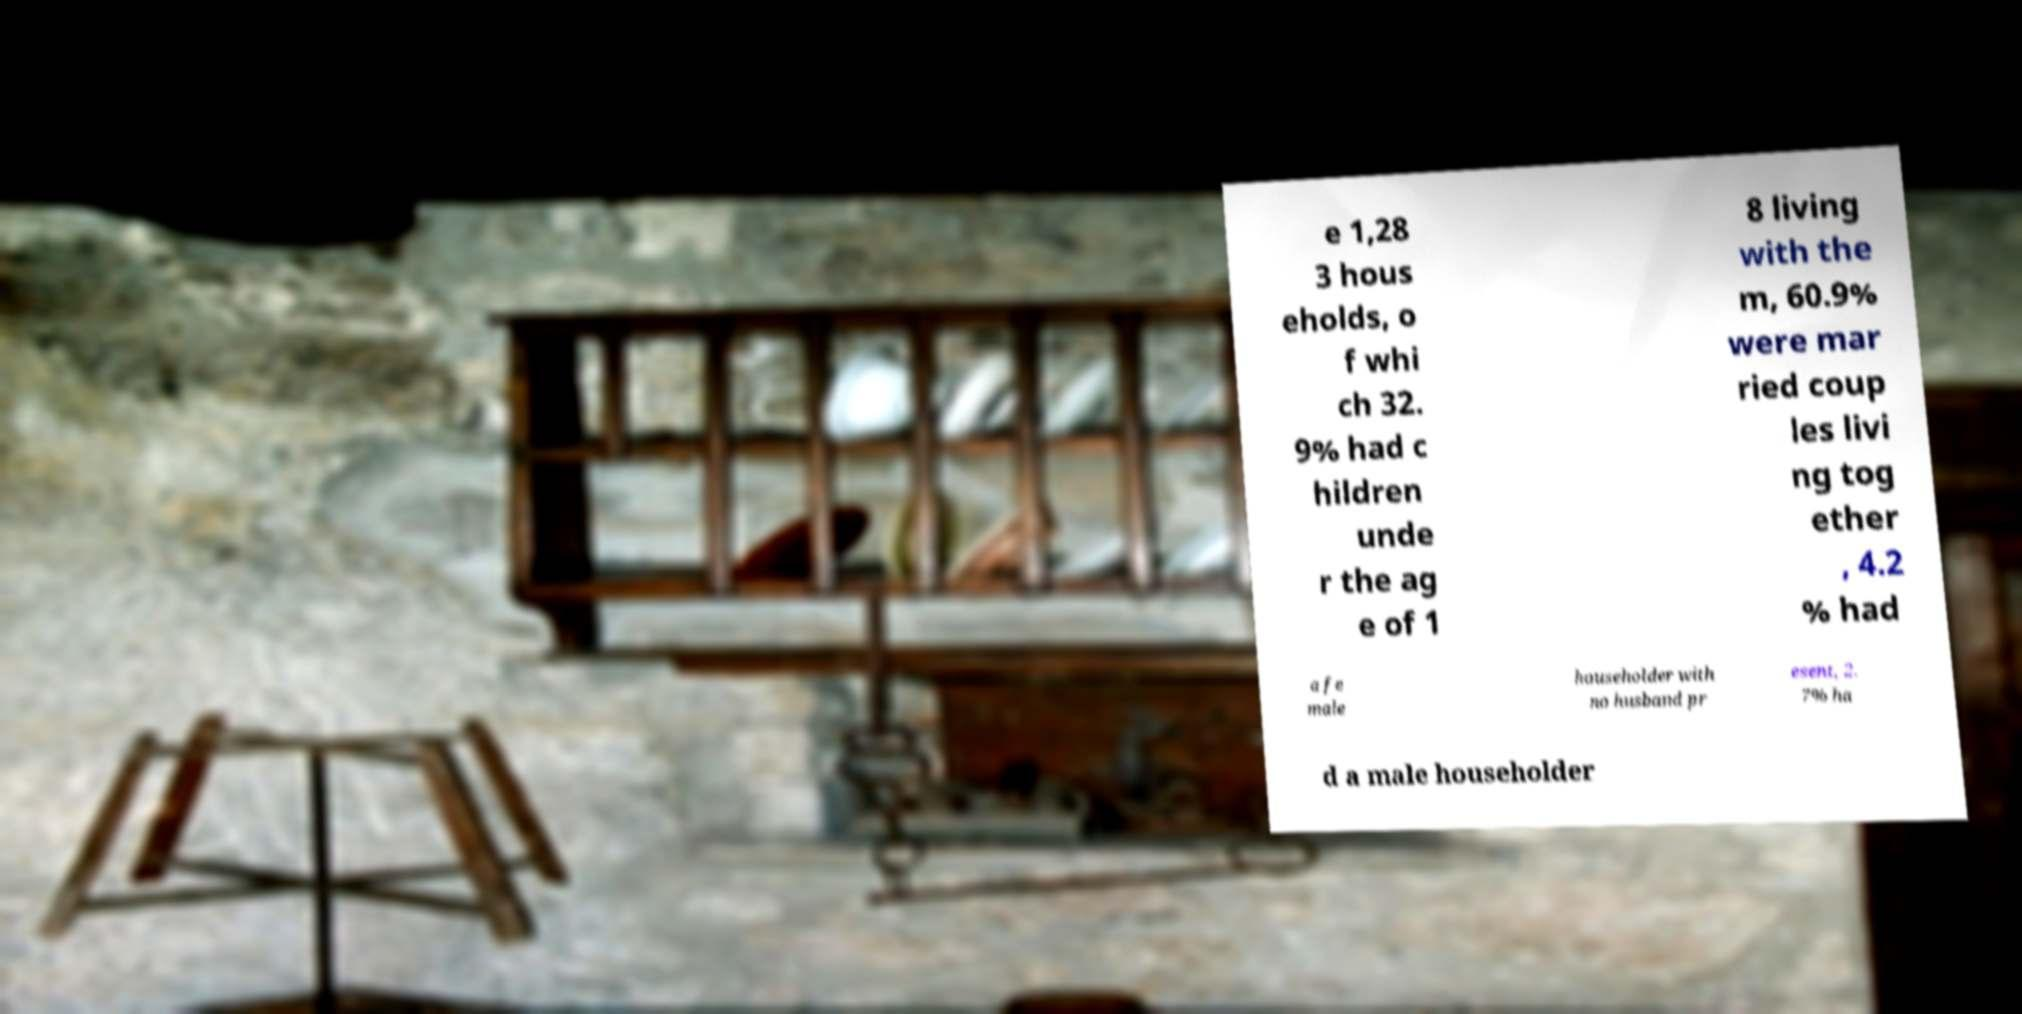There's text embedded in this image that I need extracted. Can you transcribe it verbatim? e 1,28 3 hous eholds, o f whi ch 32. 9% had c hildren unde r the ag e of 1 8 living with the m, 60.9% were mar ried coup les livi ng tog ether , 4.2 % had a fe male householder with no husband pr esent, 2. 7% ha d a male householder 